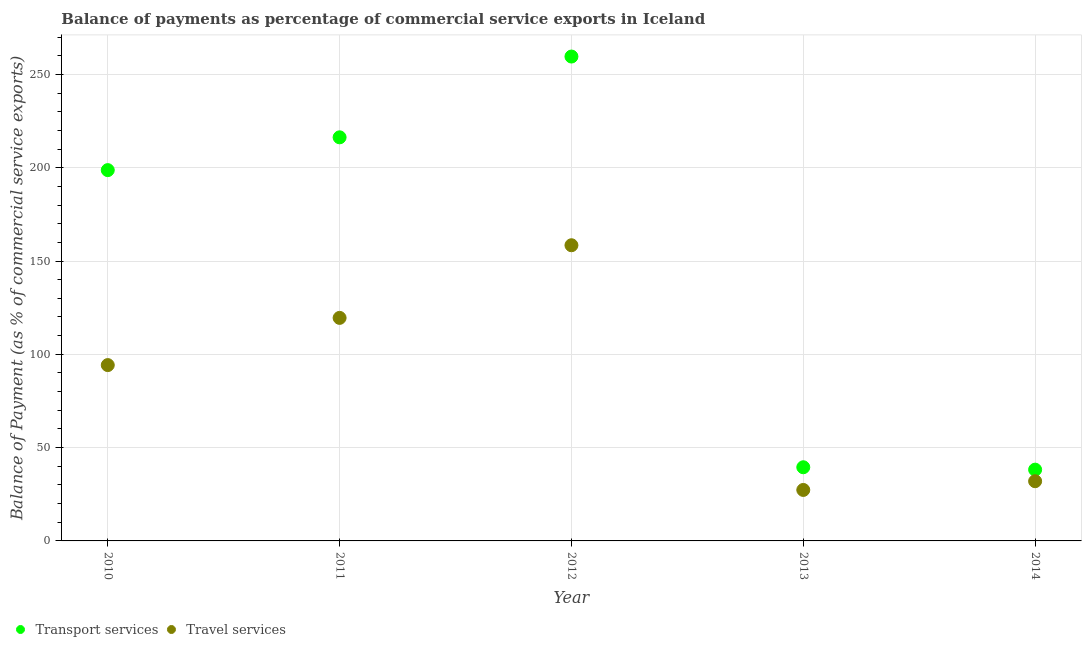How many different coloured dotlines are there?
Your answer should be compact. 2. What is the balance of payments of transport services in 2010?
Offer a terse response. 198.71. Across all years, what is the maximum balance of payments of travel services?
Provide a short and direct response. 158.45. Across all years, what is the minimum balance of payments of transport services?
Ensure brevity in your answer.  38.2. In which year was the balance of payments of transport services maximum?
Keep it short and to the point. 2012. In which year was the balance of payments of travel services minimum?
Offer a terse response. 2013. What is the total balance of payments of travel services in the graph?
Your answer should be compact. 431.51. What is the difference between the balance of payments of transport services in 2013 and that in 2014?
Provide a short and direct response. 1.28. What is the difference between the balance of payments of travel services in 2010 and the balance of payments of transport services in 2013?
Provide a short and direct response. 54.75. What is the average balance of payments of transport services per year?
Make the answer very short. 150.45. In the year 2010, what is the difference between the balance of payments of transport services and balance of payments of travel services?
Offer a terse response. 104.48. In how many years, is the balance of payments of transport services greater than 170 %?
Your response must be concise. 3. What is the ratio of the balance of payments of travel services in 2010 to that in 2012?
Keep it short and to the point. 0.59. What is the difference between the highest and the second highest balance of payments of transport services?
Make the answer very short. 43.29. What is the difference between the highest and the lowest balance of payments of transport services?
Offer a terse response. 221.37. In how many years, is the balance of payments of transport services greater than the average balance of payments of transport services taken over all years?
Your answer should be very brief. 3. Is the sum of the balance of payments of transport services in 2011 and 2012 greater than the maximum balance of payments of travel services across all years?
Offer a terse response. Yes. Does the balance of payments of travel services monotonically increase over the years?
Offer a very short reply. No. Is the balance of payments of transport services strictly greater than the balance of payments of travel services over the years?
Your response must be concise. Yes. How many years are there in the graph?
Offer a terse response. 5. Are the values on the major ticks of Y-axis written in scientific E-notation?
Keep it short and to the point. No. How many legend labels are there?
Provide a succinct answer. 2. What is the title of the graph?
Ensure brevity in your answer.  Balance of payments as percentage of commercial service exports in Iceland. What is the label or title of the X-axis?
Provide a short and direct response. Year. What is the label or title of the Y-axis?
Offer a very short reply. Balance of Payment (as % of commercial service exports). What is the Balance of Payment (as % of commercial service exports) of Transport services in 2010?
Your answer should be very brief. 198.71. What is the Balance of Payment (as % of commercial service exports) in Travel services in 2010?
Your answer should be compact. 94.23. What is the Balance of Payment (as % of commercial service exports) of Transport services in 2011?
Offer a terse response. 216.28. What is the Balance of Payment (as % of commercial service exports) of Travel services in 2011?
Ensure brevity in your answer.  119.52. What is the Balance of Payment (as % of commercial service exports) in Transport services in 2012?
Offer a very short reply. 259.57. What is the Balance of Payment (as % of commercial service exports) of Travel services in 2012?
Give a very brief answer. 158.45. What is the Balance of Payment (as % of commercial service exports) of Transport services in 2013?
Provide a succinct answer. 39.47. What is the Balance of Payment (as % of commercial service exports) of Travel services in 2013?
Make the answer very short. 27.32. What is the Balance of Payment (as % of commercial service exports) of Transport services in 2014?
Your answer should be very brief. 38.2. What is the Balance of Payment (as % of commercial service exports) of Travel services in 2014?
Provide a short and direct response. 32. Across all years, what is the maximum Balance of Payment (as % of commercial service exports) in Transport services?
Make the answer very short. 259.57. Across all years, what is the maximum Balance of Payment (as % of commercial service exports) in Travel services?
Provide a short and direct response. 158.45. Across all years, what is the minimum Balance of Payment (as % of commercial service exports) in Transport services?
Make the answer very short. 38.2. Across all years, what is the minimum Balance of Payment (as % of commercial service exports) of Travel services?
Provide a succinct answer. 27.32. What is the total Balance of Payment (as % of commercial service exports) of Transport services in the graph?
Your answer should be compact. 752.23. What is the total Balance of Payment (as % of commercial service exports) of Travel services in the graph?
Make the answer very short. 431.51. What is the difference between the Balance of Payment (as % of commercial service exports) of Transport services in 2010 and that in 2011?
Provide a short and direct response. -17.57. What is the difference between the Balance of Payment (as % of commercial service exports) in Travel services in 2010 and that in 2011?
Your answer should be very brief. -25.3. What is the difference between the Balance of Payment (as % of commercial service exports) in Transport services in 2010 and that in 2012?
Your response must be concise. -60.86. What is the difference between the Balance of Payment (as % of commercial service exports) in Travel services in 2010 and that in 2012?
Offer a very short reply. -64.22. What is the difference between the Balance of Payment (as % of commercial service exports) in Transport services in 2010 and that in 2013?
Give a very brief answer. 159.23. What is the difference between the Balance of Payment (as % of commercial service exports) of Travel services in 2010 and that in 2013?
Your answer should be compact. 66.91. What is the difference between the Balance of Payment (as % of commercial service exports) in Transport services in 2010 and that in 2014?
Your response must be concise. 160.51. What is the difference between the Balance of Payment (as % of commercial service exports) of Travel services in 2010 and that in 2014?
Provide a succinct answer. 62.23. What is the difference between the Balance of Payment (as % of commercial service exports) of Transport services in 2011 and that in 2012?
Your answer should be very brief. -43.29. What is the difference between the Balance of Payment (as % of commercial service exports) in Travel services in 2011 and that in 2012?
Keep it short and to the point. -38.93. What is the difference between the Balance of Payment (as % of commercial service exports) in Transport services in 2011 and that in 2013?
Provide a short and direct response. 176.81. What is the difference between the Balance of Payment (as % of commercial service exports) in Travel services in 2011 and that in 2013?
Ensure brevity in your answer.  92.21. What is the difference between the Balance of Payment (as % of commercial service exports) in Transport services in 2011 and that in 2014?
Provide a short and direct response. 178.08. What is the difference between the Balance of Payment (as % of commercial service exports) of Travel services in 2011 and that in 2014?
Provide a succinct answer. 87.53. What is the difference between the Balance of Payment (as % of commercial service exports) in Transport services in 2012 and that in 2013?
Your answer should be very brief. 220.1. What is the difference between the Balance of Payment (as % of commercial service exports) of Travel services in 2012 and that in 2013?
Give a very brief answer. 131.13. What is the difference between the Balance of Payment (as % of commercial service exports) in Transport services in 2012 and that in 2014?
Offer a very short reply. 221.37. What is the difference between the Balance of Payment (as % of commercial service exports) of Travel services in 2012 and that in 2014?
Provide a succinct answer. 126.45. What is the difference between the Balance of Payment (as % of commercial service exports) of Transport services in 2013 and that in 2014?
Give a very brief answer. 1.28. What is the difference between the Balance of Payment (as % of commercial service exports) in Travel services in 2013 and that in 2014?
Your answer should be compact. -4.68. What is the difference between the Balance of Payment (as % of commercial service exports) in Transport services in 2010 and the Balance of Payment (as % of commercial service exports) in Travel services in 2011?
Make the answer very short. 79.19. What is the difference between the Balance of Payment (as % of commercial service exports) of Transport services in 2010 and the Balance of Payment (as % of commercial service exports) of Travel services in 2012?
Your answer should be very brief. 40.26. What is the difference between the Balance of Payment (as % of commercial service exports) in Transport services in 2010 and the Balance of Payment (as % of commercial service exports) in Travel services in 2013?
Provide a succinct answer. 171.39. What is the difference between the Balance of Payment (as % of commercial service exports) of Transport services in 2010 and the Balance of Payment (as % of commercial service exports) of Travel services in 2014?
Your answer should be compact. 166.71. What is the difference between the Balance of Payment (as % of commercial service exports) of Transport services in 2011 and the Balance of Payment (as % of commercial service exports) of Travel services in 2012?
Your answer should be very brief. 57.83. What is the difference between the Balance of Payment (as % of commercial service exports) in Transport services in 2011 and the Balance of Payment (as % of commercial service exports) in Travel services in 2013?
Provide a short and direct response. 188.97. What is the difference between the Balance of Payment (as % of commercial service exports) of Transport services in 2011 and the Balance of Payment (as % of commercial service exports) of Travel services in 2014?
Provide a succinct answer. 184.29. What is the difference between the Balance of Payment (as % of commercial service exports) in Transport services in 2012 and the Balance of Payment (as % of commercial service exports) in Travel services in 2013?
Make the answer very short. 232.26. What is the difference between the Balance of Payment (as % of commercial service exports) in Transport services in 2012 and the Balance of Payment (as % of commercial service exports) in Travel services in 2014?
Ensure brevity in your answer.  227.58. What is the difference between the Balance of Payment (as % of commercial service exports) in Transport services in 2013 and the Balance of Payment (as % of commercial service exports) in Travel services in 2014?
Ensure brevity in your answer.  7.48. What is the average Balance of Payment (as % of commercial service exports) of Transport services per year?
Ensure brevity in your answer.  150.45. What is the average Balance of Payment (as % of commercial service exports) in Travel services per year?
Offer a terse response. 86.3. In the year 2010, what is the difference between the Balance of Payment (as % of commercial service exports) in Transport services and Balance of Payment (as % of commercial service exports) in Travel services?
Your response must be concise. 104.48. In the year 2011, what is the difference between the Balance of Payment (as % of commercial service exports) in Transport services and Balance of Payment (as % of commercial service exports) in Travel services?
Your answer should be compact. 96.76. In the year 2012, what is the difference between the Balance of Payment (as % of commercial service exports) of Transport services and Balance of Payment (as % of commercial service exports) of Travel services?
Your answer should be very brief. 101.12. In the year 2013, what is the difference between the Balance of Payment (as % of commercial service exports) in Transport services and Balance of Payment (as % of commercial service exports) in Travel services?
Your answer should be very brief. 12.16. In the year 2014, what is the difference between the Balance of Payment (as % of commercial service exports) of Transport services and Balance of Payment (as % of commercial service exports) of Travel services?
Provide a succinct answer. 6.2. What is the ratio of the Balance of Payment (as % of commercial service exports) in Transport services in 2010 to that in 2011?
Your response must be concise. 0.92. What is the ratio of the Balance of Payment (as % of commercial service exports) of Travel services in 2010 to that in 2011?
Make the answer very short. 0.79. What is the ratio of the Balance of Payment (as % of commercial service exports) of Transport services in 2010 to that in 2012?
Provide a short and direct response. 0.77. What is the ratio of the Balance of Payment (as % of commercial service exports) in Travel services in 2010 to that in 2012?
Your answer should be very brief. 0.59. What is the ratio of the Balance of Payment (as % of commercial service exports) in Transport services in 2010 to that in 2013?
Offer a terse response. 5.03. What is the ratio of the Balance of Payment (as % of commercial service exports) of Travel services in 2010 to that in 2013?
Offer a terse response. 3.45. What is the ratio of the Balance of Payment (as % of commercial service exports) in Transport services in 2010 to that in 2014?
Provide a succinct answer. 5.2. What is the ratio of the Balance of Payment (as % of commercial service exports) in Travel services in 2010 to that in 2014?
Offer a very short reply. 2.94. What is the ratio of the Balance of Payment (as % of commercial service exports) of Transport services in 2011 to that in 2012?
Offer a terse response. 0.83. What is the ratio of the Balance of Payment (as % of commercial service exports) in Travel services in 2011 to that in 2012?
Make the answer very short. 0.75. What is the ratio of the Balance of Payment (as % of commercial service exports) of Transport services in 2011 to that in 2013?
Your answer should be very brief. 5.48. What is the ratio of the Balance of Payment (as % of commercial service exports) in Travel services in 2011 to that in 2013?
Give a very brief answer. 4.38. What is the ratio of the Balance of Payment (as % of commercial service exports) in Transport services in 2011 to that in 2014?
Offer a terse response. 5.66. What is the ratio of the Balance of Payment (as % of commercial service exports) of Travel services in 2011 to that in 2014?
Your response must be concise. 3.74. What is the ratio of the Balance of Payment (as % of commercial service exports) in Transport services in 2012 to that in 2013?
Your response must be concise. 6.58. What is the ratio of the Balance of Payment (as % of commercial service exports) in Travel services in 2012 to that in 2013?
Make the answer very short. 5.8. What is the ratio of the Balance of Payment (as % of commercial service exports) in Transport services in 2012 to that in 2014?
Ensure brevity in your answer.  6.8. What is the ratio of the Balance of Payment (as % of commercial service exports) of Travel services in 2012 to that in 2014?
Your response must be concise. 4.95. What is the ratio of the Balance of Payment (as % of commercial service exports) of Transport services in 2013 to that in 2014?
Your answer should be very brief. 1.03. What is the ratio of the Balance of Payment (as % of commercial service exports) in Travel services in 2013 to that in 2014?
Give a very brief answer. 0.85. What is the difference between the highest and the second highest Balance of Payment (as % of commercial service exports) in Transport services?
Offer a terse response. 43.29. What is the difference between the highest and the second highest Balance of Payment (as % of commercial service exports) in Travel services?
Your answer should be very brief. 38.93. What is the difference between the highest and the lowest Balance of Payment (as % of commercial service exports) in Transport services?
Make the answer very short. 221.37. What is the difference between the highest and the lowest Balance of Payment (as % of commercial service exports) in Travel services?
Make the answer very short. 131.13. 